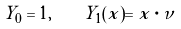<formula> <loc_0><loc_0><loc_500><loc_500>Y _ { 0 } = 1 , \quad Y _ { 1 } ( x ) = x \cdot \nu</formula> 